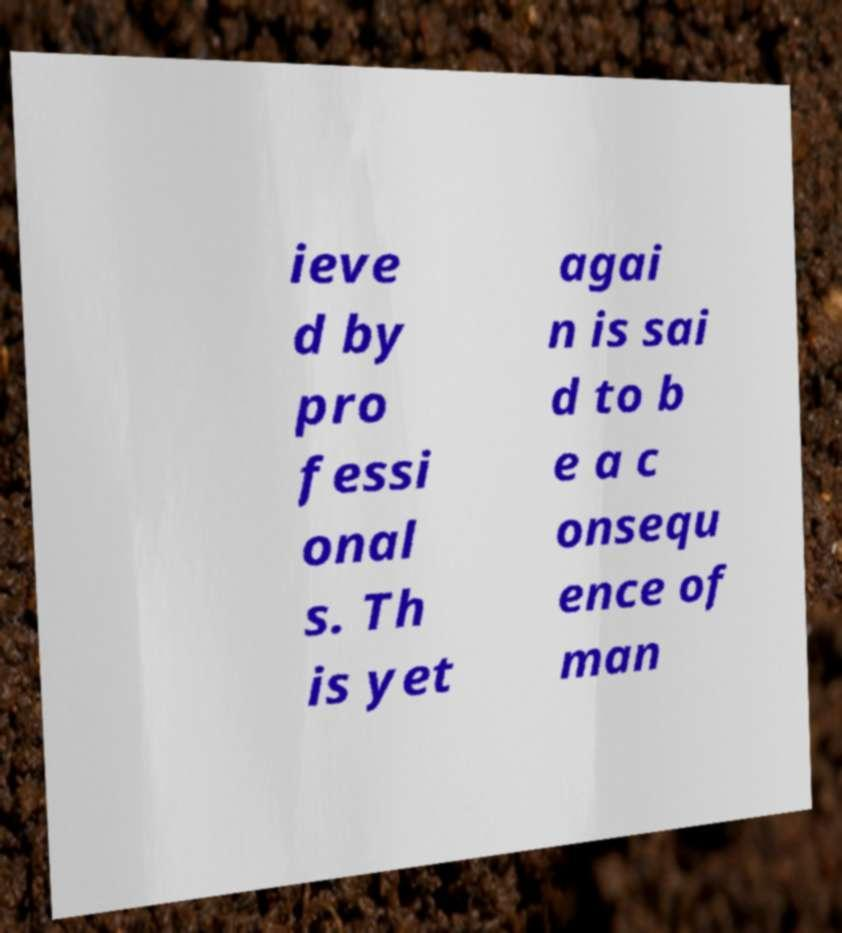For documentation purposes, I need the text within this image transcribed. Could you provide that? ieve d by pro fessi onal s. Th is yet agai n is sai d to b e a c onsequ ence of man 